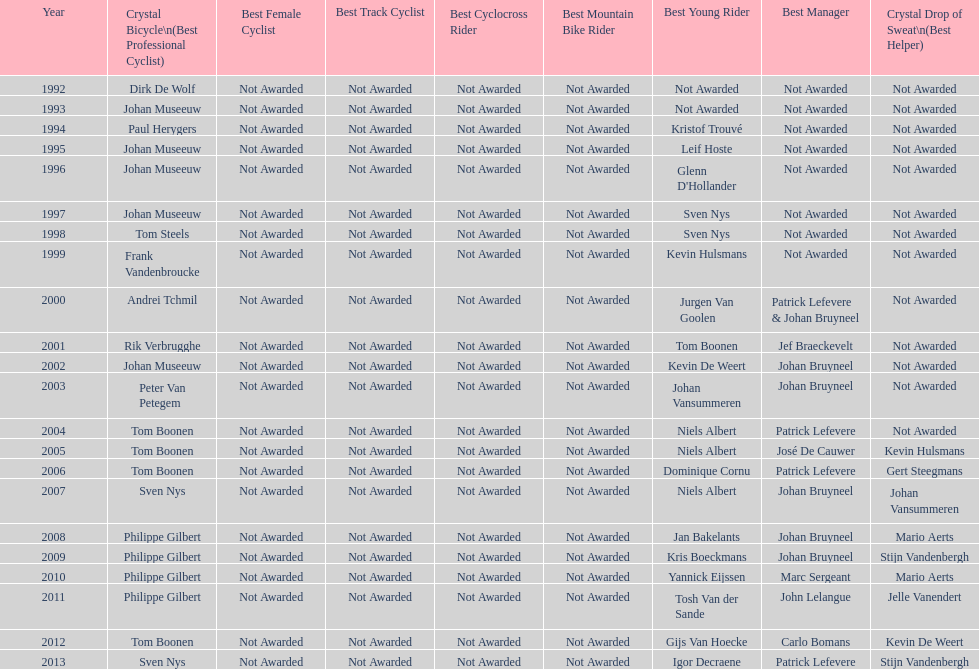What is the average number of times johan museeuw starred? 5. 